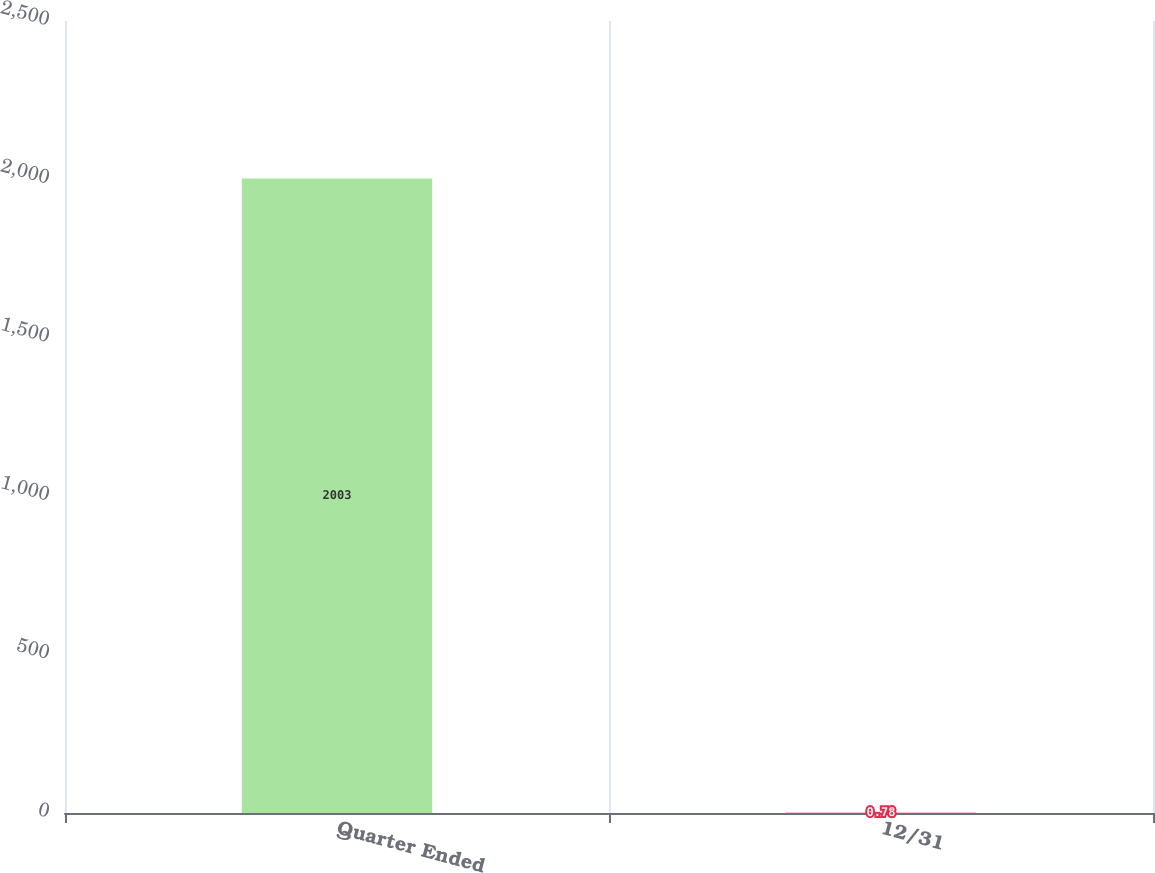<chart> <loc_0><loc_0><loc_500><loc_500><bar_chart><fcel>Quarter Ended<fcel>12/31<nl><fcel>2003<fcel>0.78<nl></chart> 